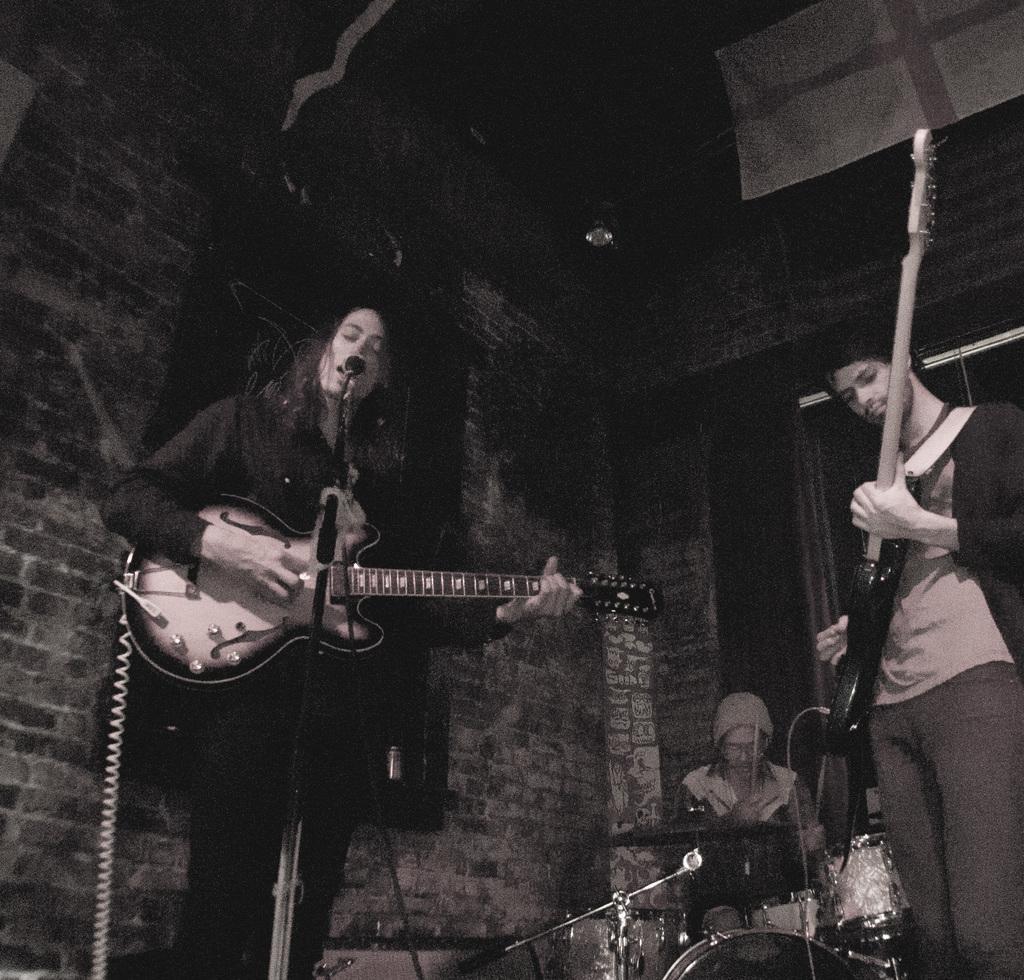Can you describe this image briefly? Bottom left side of the image a woman is standing and playing guitar and singing. Bottom right side of the image a man is standing and playing guitar. Behind him a person is sitting and playing drums. Behind them there is a wall. At the top of the image there is a roof. 